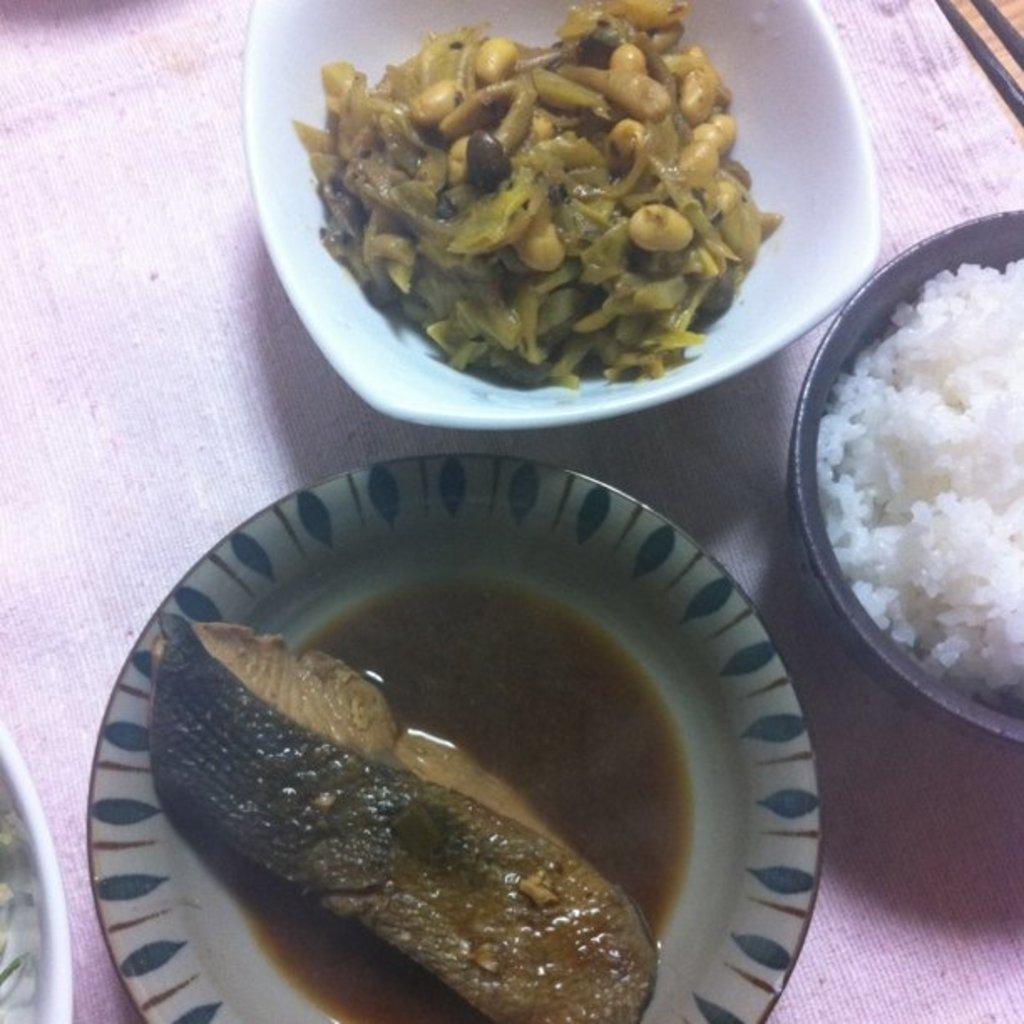Can you describe this image briefly? In this image, there are three bowls with the food items in it. This looks like a cloth, which is light pink in color. 